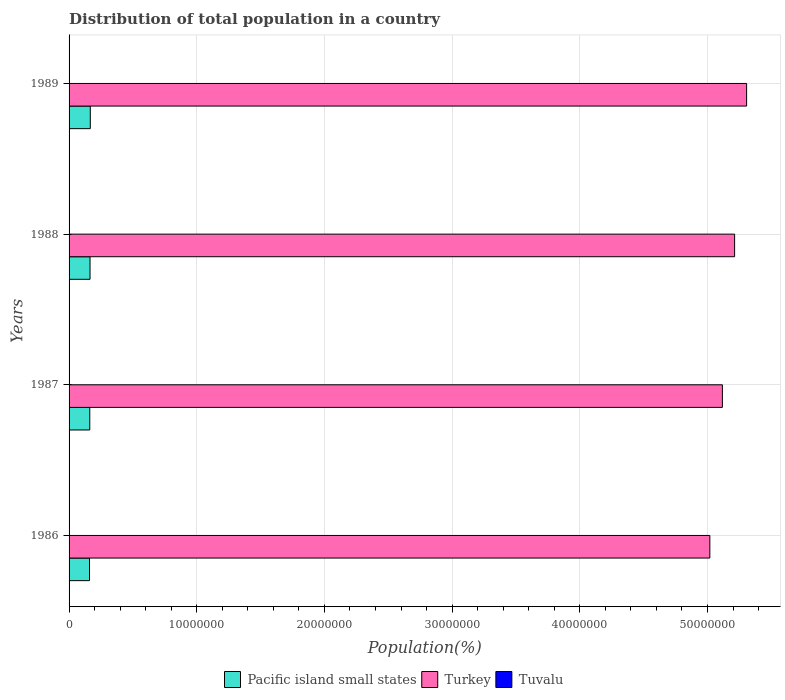How many different coloured bars are there?
Offer a terse response. 3. Are the number of bars per tick equal to the number of legend labels?
Ensure brevity in your answer.  Yes. Are the number of bars on each tick of the Y-axis equal?
Your answer should be very brief. Yes. How many bars are there on the 2nd tick from the top?
Your answer should be very brief. 3. How many bars are there on the 2nd tick from the bottom?
Your response must be concise. 3. What is the label of the 3rd group of bars from the top?
Your answer should be very brief. 1987. In how many cases, is the number of bars for a given year not equal to the number of legend labels?
Offer a terse response. 0. What is the population of in Tuvalu in 1988?
Offer a very short reply. 8889. Across all years, what is the maximum population of in Pacific island small states?
Your answer should be very brief. 1.66e+06. Across all years, what is the minimum population of in Turkey?
Give a very brief answer. 5.02e+07. In which year was the population of in Turkey maximum?
Your response must be concise. 1989. What is the total population of in Pacific island small states in the graph?
Your response must be concise. 6.53e+06. What is the difference between the population of in Tuvalu in 1986 and that in 1987?
Your answer should be very brief. -80. What is the difference between the population of in Pacific island small states in 1988 and the population of in Turkey in 1986?
Provide a succinct answer. -4.85e+07. What is the average population of in Tuvalu per year?
Offer a terse response. 8850. In the year 1987, what is the difference between the population of in Pacific island small states and population of in Turkey?
Your response must be concise. -4.95e+07. In how many years, is the population of in Tuvalu greater than 46000000 %?
Your response must be concise. 0. What is the ratio of the population of in Pacific island small states in 1986 to that in 1987?
Your answer should be very brief. 0.99. What is the difference between the highest and the second highest population of in Pacific island small states?
Keep it short and to the point. 2.02e+04. What is the difference between the highest and the lowest population of in Pacific island small states?
Provide a succinct answer. 6.06e+04. What does the 1st bar from the top in 1987 represents?
Your response must be concise. Tuvalu. What does the 3rd bar from the bottom in 1988 represents?
Keep it short and to the point. Tuvalu. Is it the case that in every year, the sum of the population of in Pacific island small states and population of in Turkey is greater than the population of in Tuvalu?
Provide a succinct answer. Yes. Are all the bars in the graph horizontal?
Provide a short and direct response. Yes. How many years are there in the graph?
Offer a very short reply. 4. What is the difference between two consecutive major ticks on the X-axis?
Offer a very short reply. 1.00e+07. Are the values on the major ticks of X-axis written in scientific E-notation?
Your response must be concise. No. Does the graph contain grids?
Give a very brief answer. Yes. How are the legend labels stacked?
Provide a short and direct response. Horizontal. What is the title of the graph?
Make the answer very short. Distribution of total population in a country. What is the label or title of the X-axis?
Your response must be concise. Population(%). What is the Population(%) in Pacific island small states in 1986?
Your answer should be very brief. 1.60e+06. What is the Population(%) of Turkey in 1986?
Provide a succinct answer. 5.02e+07. What is the Population(%) in Tuvalu in 1986?
Your answer should be compact. 8741. What is the Population(%) of Pacific island small states in 1987?
Provide a short and direct response. 1.62e+06. What is the Population(%) in Turkey in 1987?
Your answer should be very brief. 5.12e+07. What is the Population(%) in Tuvalu in 1987?
Make the answer very short. 8821. What is the Population(%) of Pacific island small states in 1988?
Provide a short and direct response. 1.64e+06. What is the Population(%) in Turkey in 1988?
Keep it short and to the point. 5.21e+07. What is the Population(%) in Tuvalu in 1988?
Give a very brief answer. 8889. What is the Population(%) of Pacific island small states in 1989?
Your response must be concise. 1.66e+06. What is the Population(%) in Turkey in 1989?
Offer a very short reply. 5.31e+07. What is the Population(%) in Tuvalu in 1989?
Your answer should be compact. 8949. Across all years, what is the maximum Population(%) in Pacific island small states?
Offer a terse response. 1.66e+06. Across all years, what is the maximum Population(%) of Turkey?
Provide a short and direct response. 5.31e+07. Across all years, what is the maximum Population(%) of Tuvalu?
Make the answer very short. 8949. Across all years, what is the minimum Population(%) of Pacific island small states?
Provide a succinct answer. 1.60e+06. Across all years, what is the minimum Population(%) of Turkey?
Your response must be concise. 5.02e+07. Across all years, what is the minimum Population(%) in Tuvalu?
Offer a very short reply. 8741. What is the total Population(%) of Pacific island small states in the graph?
Provide a succinct answer. 6.53e+06. What is the total Population(%) in Turkey in the graph?
Your answer should be very brief. 2.07e+08. What is the total Population(%) of Tuvalu in the graph?
Your answer should be very brief. 3.54e+04. What is the difference between the Population(%) in Pacific island small states in 1986 and that in 1987?
Offer a very short reply. -2.11e+04. What is the difference between the Population(%) of Turkey in 1986 and that in 1987?
Provide a succinct answer. -9.82e+05. What is the difference between the Population(%) in Tuvalu in 1986 and that in 1987?
Make the answer very short. -80. What is the difference between the Population(%) in Pacific island small states in 1986 and that in 1988?
Provide a succinct answer. -4.03e+04. What is the difference between the Population(%) in Turkey in 1986 and that in 1988?
Offer a very short reply. -1.94e+06. What is the difference between the Population(%) in Tuvalu in 1986 and that in 1988?
Ensure brevity in your answer.  -148. What is the difference between the Population(%) in Pacific island small states in 1986 and that in 1989?
Give a very brief answer. -6.06e+04. What is the difference between the Population(%) in Turkey in 1986 and that in 1989?
Offer a terse response. -2.88e+06. What is the difference between the Population(%) in Tuvalu in 1986 and that in 1989?
Keep it short and to the point. -208. What is the difference between the Population(%) of Pacific island small states in 1987 and that in 1988?
Your answer should be compact. -1.93e+04. What is the difference between the Population(%) in Turkey in 1987 and that in 1988?
Offer a very short reply. -9.58e+05. What is the difference between the Population(%) in Tuvalu in 1987 and that in 1988?
Give a very brief answer. -68. What is the difference between the Population(%) of Pacific island small states in 1987 and that in 1989?
Provide a succinct answer. -3.95e+04. What is the difference between the Population(%) of Turkey in 1987 and that in 1989?
Your answer should be compact. -1.90e+06. What is the difference between the Population(%) in Tuvalu in 1987 and that in 1989?
Provide a succinct answer. -128. What is the difference between the Population(%) of Pacific island small states in 1988 and that in 1989?
Keep it short and to the point. -2.02e+04. What is the difference between the Population(%) in Turkey in 1988 and that in 1989?
Keep it short and to the point. -9.40e+05. What is the difference between the Population(%) in Tuvalu in 1988 and that in 1989?
Give a very brief answer. -60. What is the difference between the Population(%) of Pacific island small states in 1986 and the Population(%) of Turkey in 1987?
Provide a succinct answer. -4.96e+07. What is the difference between the Population(%) in Pacific island small states in 1986 and the Population(%) in Tuvalu in 1987?
Give a very brief answer. 1.59e+06. What is the difference between the Population(%) in Turkey in 1986 and the Population(%) in Tuvalu in 1987?
Ensure brevity in your answer.  5.02e+07. What is the difference between the Population(%) in Pacific island small states in 1986 and the Population(%) in Turkey in 1988?
Make the answer very short. -5.05e+07. What is the difference between the Population(%) of Pacific island small states in 1986 and the Population(%) of Tuvalu in 1988?
Make the answer very short. 1.59e+06. What is the difference between the Population(%) of Turkey in 1986 and the Population(%) of Tuvalu in 1988?
Your answer should be compact. 5.02e+07. What is the difference between the Population(%) in Pacific island small states in 1986 and the Population(%) in Turkey in 1989?
Offer a terse response. -5.15e+07. What is the difference between the Population(%) in Pacific island small states in 1986 and the Population(%) in Tuvalu in 1989?
Ensure brevity in your answer.  1.59e+06. What is the difference between the Population(%) of Turkey in 1986 and the Population(%) of Tuvalu in 1989?
Give a very brief answer. 5.02e+07. What is the difference between the Population(%) of Pacific island small states in 1987 and the Population(%) of Turkey in 1988?
Keep it short and to the point. -5.05e+07. What is the difference between the Population(%) of Pacific island small states in 1987 and the Population(%) of Tuvalu in 1988?
Provide a short and direct response. 1.61e+06. What is the difference between the Population(%) in Turkey in 1987 and the Population(%) in Tuvalu in 1988?
Give a very brief answer. 5.12e+07. What is the difference between the Population(%) in Pacific island small states in 1987 and the Population(%) in Turkey in 1989?
Your answer should be very brief. -5.14e+07. What is the difference between the Population(%) in Pacific island small states in 1987 and the Population(%) in Tuvalu in 1989?
Offer a terse response. 1.61e+06. What is the difference between the Population(%) of Turkey in 1987 and the Population(%) of Tuvalu in 1989?
Make the answer very short. 5.12e+07. What is the difference between the Population(%) in Pacific island small states in 1988 and the Population(%) in Turkey in 1989?
Your answer should be very brief. -5.14e+07. What is the difference between the Population(%) in Pacific island small states in 1988 and the Population(%) in Tuvalu in 1989?
Offer a terse response. 1.63e+06. What is the difference between the Population(%) of Turkey in 1988 and the Population(%) of Tuvalu in 1989?
Your answer should be compact. 5.21e+07. What is the average Population(%) of Pacific island small states per year?
Your answer should be very brief. 1.63e+06. What is the average Population(%) in Turkey per year?
Keep it short and to the point. 5.16e+07. What is the average Population(%) in Tuvalu per year?
Keep it short and to the point. 8850. In the year 1986, what is the difference between the Population(%) of Pacific island small states and Population(%) of Turkey?
Offer a terse response. -4.86e+07. In the year 1986, what is the difference between the Population(%) of Pacific island small states and Population(%) of Tuvalu?
Offer a very short reply. 1.59e+06. In the year 1986, what is the difference between the Population(%) in Turkey and Population(%) in Tuvalu?
Your answer should be very brief. 5.02e+07. In the year 1987, what is the difference between the Population(%) in Pacific island small states and Population(%) in Turkey?
Keep it short and to the point. -4.95e+07. In the year 1987, what is the difference between the Population(%) in Pacific island small states and Population(%) in Tuvalu?
Offer a very short reply. 1.61e+06. In the year 1987, what is the difference between the Population(%) in Turkey and Population(%) in Tuvalu?
Your answer should be compact. 5.12e+07. In the year 1988, what is the difference between the Population(%) in Pacific island small states and Population(%) in Turkey?
Offer a very short reply. -5.05e+07. In the year 1988, what is the difference between the Population(%) of Pacific island small states and Population(%) of Tuvalu?
Keep it short and to the point. 1.63e+06. In the year 1988, what is the difference between the Population(%) of Turkey and Population(%) of Tuvalu?
Offer a terse response. 5.21e+07. In the year 1989, what is the difference between the Population(%) in Pacific island small states and Population(%) in Turkey?
Provide a short and direct response. -5.14e+07. In the year 1989, what is the difference between the Population(%) in Pacific island small states and Population(%) in Tuvalu?
Offer a terse response. 1.65e+06. In the year 1989, what is the difference between the Population(%) in Turkey and Population(%) in Tuvalu?
Offer a terse response. 5.31e+07. What is the ratio of the Population(%) of Pacific island small states in 1986 to that in 1987?
Keep it short and to the point. 0.99. What is the ratio of the Population(%) of Turkey in 1986 to that in 1987?
Provide a short and direct response. 0.98. What is the ratio of the Population(%) of Tuvalu in 1986 to that in 1987?
Offer a terse response. 0.99. What is the ratio of the Population(%) in Pacific island small states in 1986 to that in 1988?
Make the answer very short. 0.98. What is the ratio of the Population(%) in Turkey in 1986 to that in 1988?
Your answer should be very brief. 0.96. What is the ratio of the Population(%) in Tuvalu in 1986 to that in 1988?
Provide a succinct answer. 0.98. What is the ratio of the Population(%) of Pacific island small states in 1986 to that in 1989?
Ensure brevity in your answer.  0.96. What is the ratio of the Population(%) of Turkey in 1986 to that in 1989?
Ensure brevity in your answer.  0.95. What is the ratio of the Population(%) of Tuvalu in 1986 to that in 1989?
Ensure brevity in your answer.  0.98. What is the ratio of the Population(%) of Pacific island small states in 1987 to that in 1988?
Provide a short and direct response. 0.99. What is the ratio of the Population(%) of Turkey in 1987 to that in 1988?
Offer a very short reply. 0.98. What is the ratio of the Population(%) in Pacific island small states in 1987 to that in 1989?
Give a very brief answer. 0.98. What is the ratio of the Population(%) in Turkey in 1987 to that in 1989?
Provide a succinct answer. 0.96. What is the ratio of the Population(%) in Tuvalu in 1987 to that in 1989?
Your answer should be compact. 0.99. What is the ratio of the Population(%) in Pacific island small states in 1988 to that in 1989?
Your answer should be very brief. 0.99. What is the ratio of the Population(%) in Turkey in 1988 to that in 1989?
Offer a very short reply. 0.98. What is the difference between the highest and the second highest Population(%) of Pacific island small states?
Provide a succinct answer. 2.02e+04. What is the difference between the highest and the second highest Population(%) of Turkey?
Offer a very short reply. 9.40e+05. What is the difference between the highest and the second highest Population(%) of Tuvalu?
Keep it short and to the point. 60. What is the difference between the highest and the lowest Population(%) in Pacific island small states?
Keep it short and to the point. 6.06e+04. What is the difference between the highest and the lowest Population(%) in Turkey?
Provide a short and direct response. 2.88e+06. What is the difference between the highest and the lowest Population(%) of Tuvalu?
Your response must be concise. 208. 